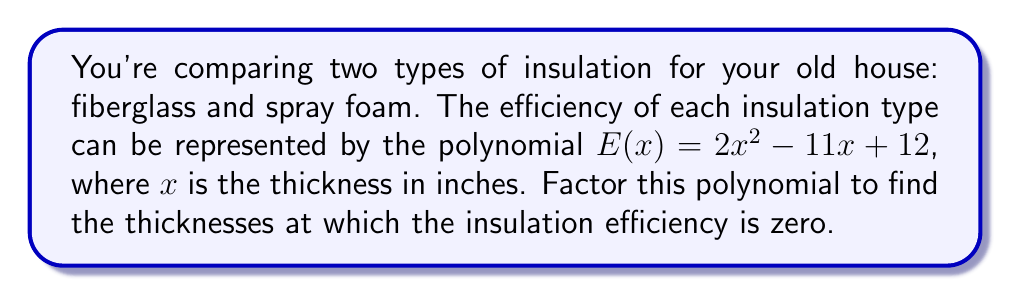Can you answer this question? To factor the polynomial $E(x) = 2x^2 - 11x + 12$, we'll follow these steps:

1) First, we identify that this is a quadratic equation in the form $ax^2 + bx + c$, where:
   $a = 2$, $b = -11$, and $c = 12$

2) We'll use the quadratic formula: $x = \frac{-b \pm \sqrt{b^2 - 4ac}}{2a}$

3) Substituting our values:
   $x = \frac{11 \pm \sqrt{(-11)^2 - 4(2)(12)}}{2(2)}$

4) Simplify under the square root:
   $x = \frac{11 \pm \sqrt{121 - 96}}{4} = \frac{11 \pm \sqrt{25}}{4} = \frac{11 \pm 5}{4}$

5) This gives us two solutions:
   $x_1 = \frac{11 + 5}{4} = \frac{16}{4} = 4$
   $x_2 = \frac{11 - 5}{4} = \frac{6}{4} = \frac{3}{2}$

6) Therefore, we can factor the polynomial as:
   $E(x) = 2(x - 4)(x - \frac{3}{2})$

This factored form shows that the efficiency is zero when $x = 4$ or $x = \frac{3}{2}$.
Answer: $E(x) = 2(x - 4)(x - \frac{3}{2})$ 